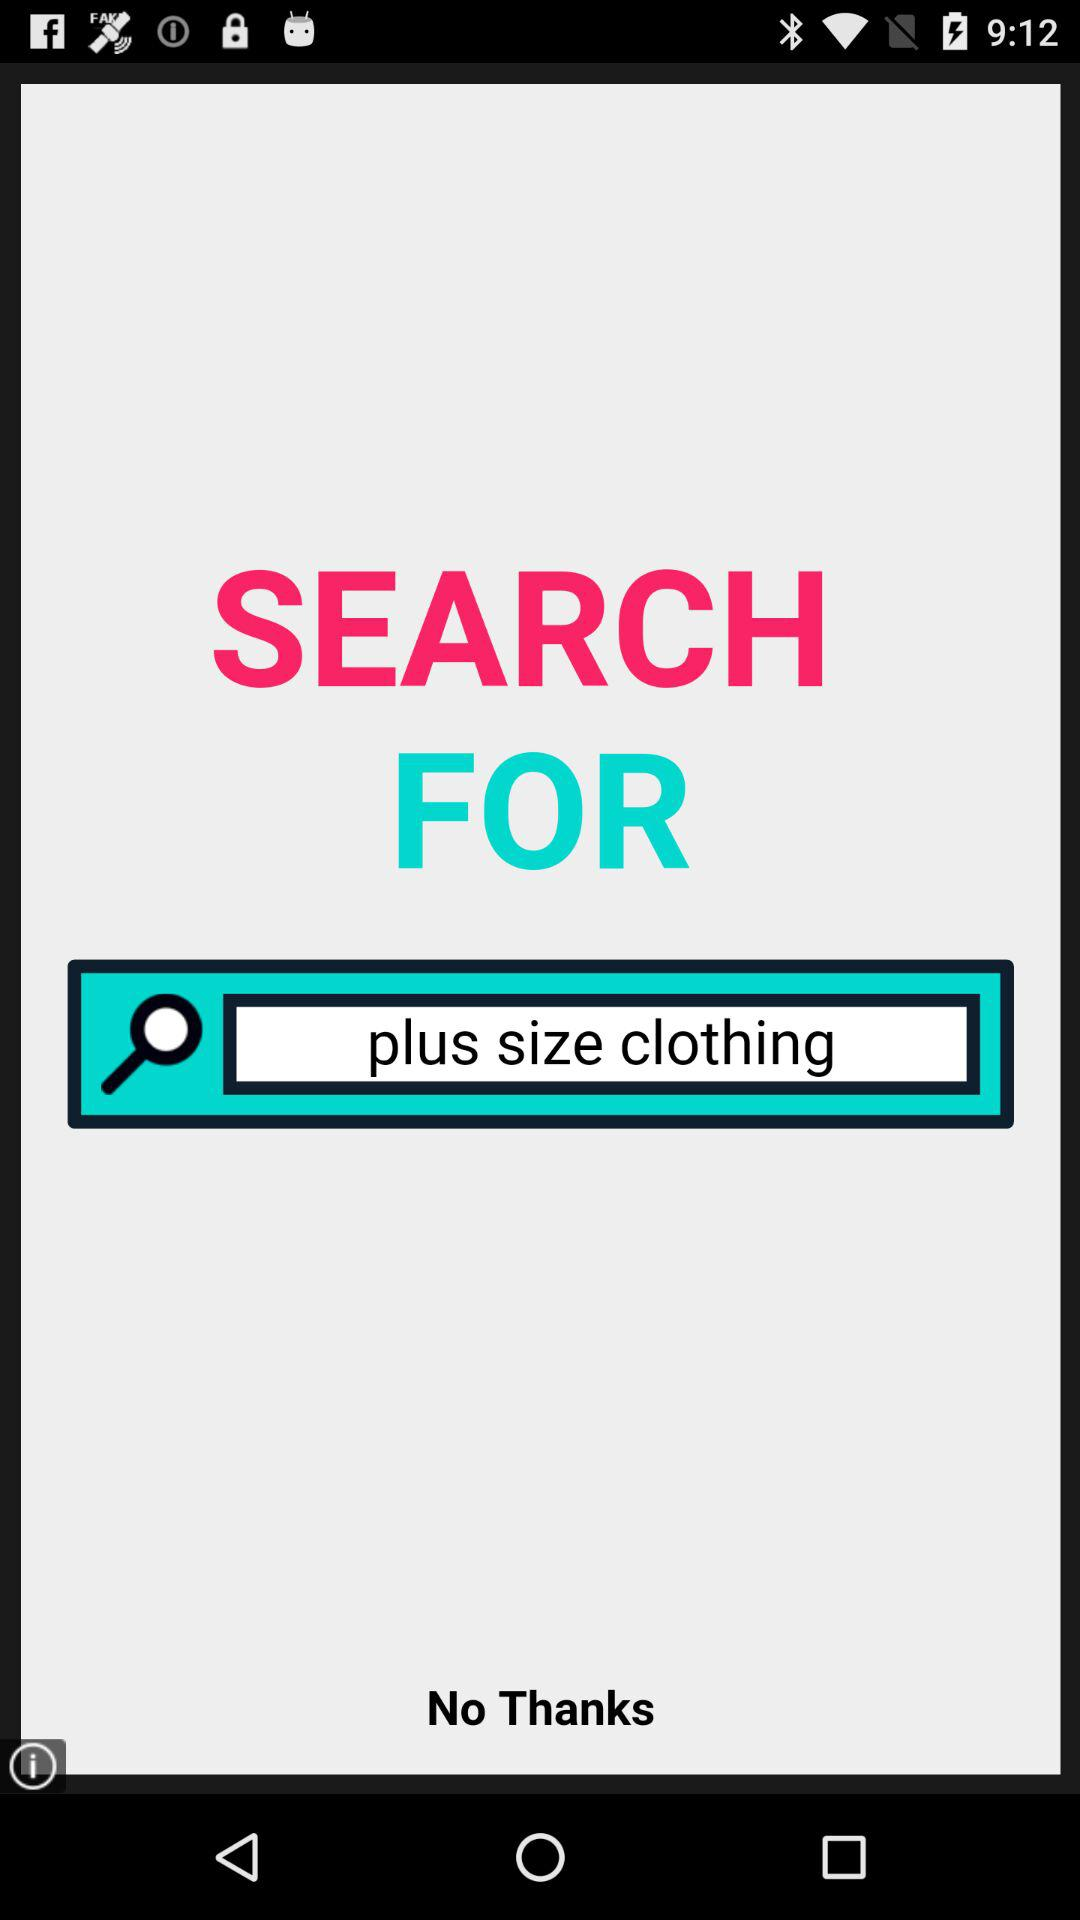How many search results are there?
When the provided information is insufficient, respond with <no answer>. <no answer> 